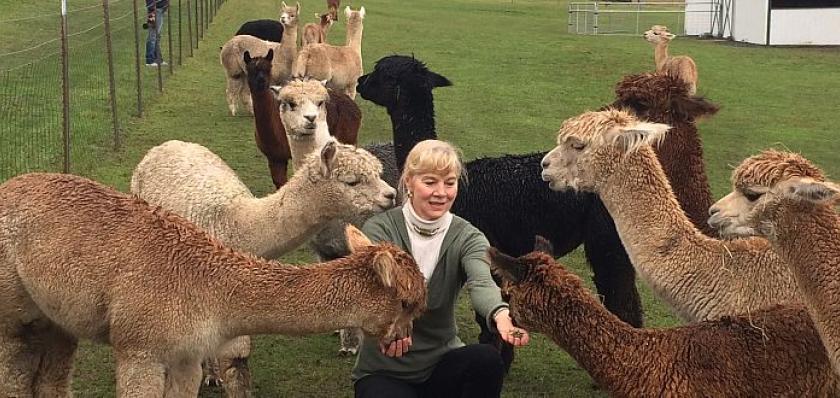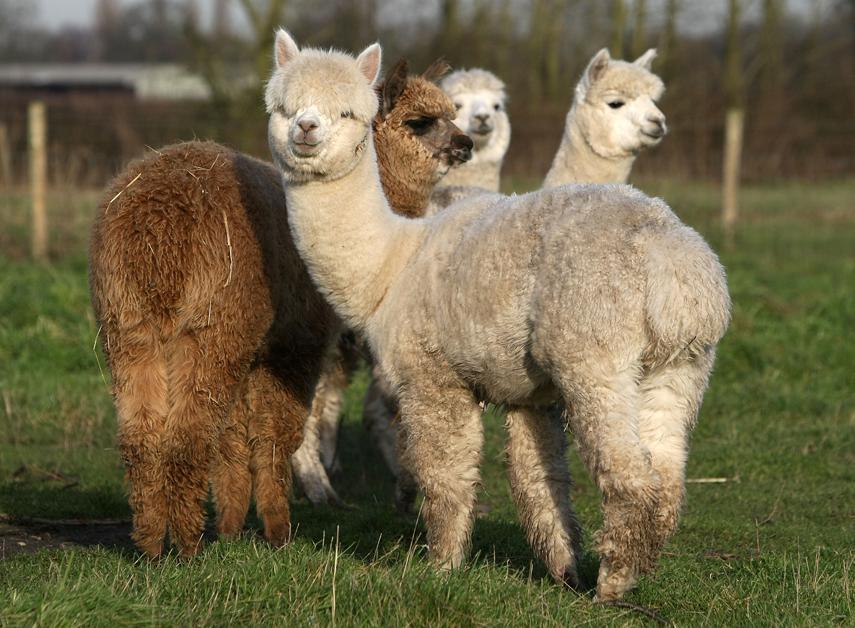The first image is the image on the left, the second image is the image on the right. Evaluate the accuracy of this statement regarding the images: "IN at least one image there are six llamas standing on grass.". Is it true? Answer yes or no. Yes. The first image is the image on the left, the second image is the image on the right. Analyze the images presented: Is the assertion "An image shows just one llama, which is standing in profile on dry ground, with its face and body turned the same way." valid? Answer yes or no. No. 